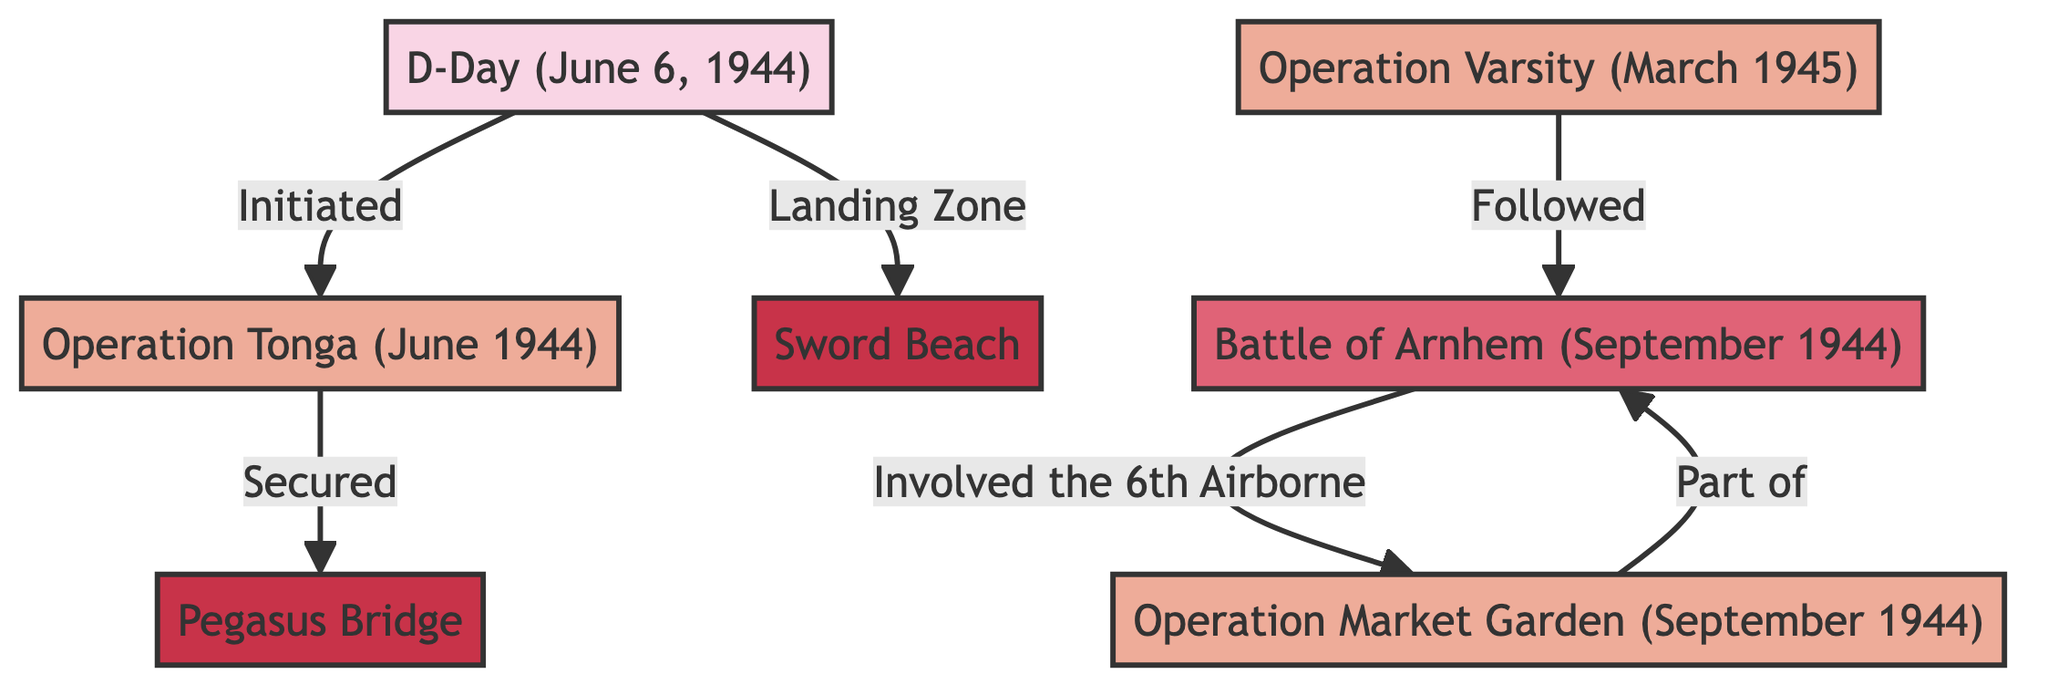What is the label of the first node in the diagram? The first node in the diagram is labeled "D-Day (June 6, 1944)", as it is the starting point for the directed graph.
Answer: D-Day (June 6, 1944) How many nodes are present in the diagram? The diagram contains a total of 7 nodes, which include campaigns, operations, battles, and locations related to the 6th Airborne Division's involvement.
Answer: 7 What operation is associated with D-Day? D-Day is associated with "Operation Tonga", as indicated by the directed edge that shows "D-Day" initiating "Operation Tonga".
Answer: Operation Tonga Which battle was part of Operation Market Garden? The "Battle of Arnhem" is specified in the diagram as being part of "Operation Market Garden" based on the directed edge connecting these two nodes.
Answer: Battle of Arnhem What location did the 6th Airborne Division secure on D-Day? The 6th Airborne Division secured "Pegasus Bridge" during the execution of "Operation Tonga", as shown by the directed relationship in the graph.
Answer: Pegasus Bridge How is Operation Varsity related to the Battle of Arnhem? "Operation Varsity" is shown to have followed the "Battle of Arnhem", indicating a temporal relationship where one operation occurs after the other.
Answer: Followed Which operation involved the 6th Airborne Division in September 1944? "Operation Market Garden" involved the 6th Airborne Division, as depicted by the edge labeled "Involved the 6th Airborne" that connects to the "Battle of Arnhem".
Answer: Operation Market Garden What is the landing zone noted in the diagram? The landing zone mentioned is "Sword Beach", as it is specifically referenced in the diagram showing a relationship with D-Day.
Answer: Sword Beach Identify an operation that started with an airborne assault. "Operation Tonga" is identified as starting with an airborne assault, indicated by the connection from D-Day that mentions this operation.
Answer: Operation Tonga 